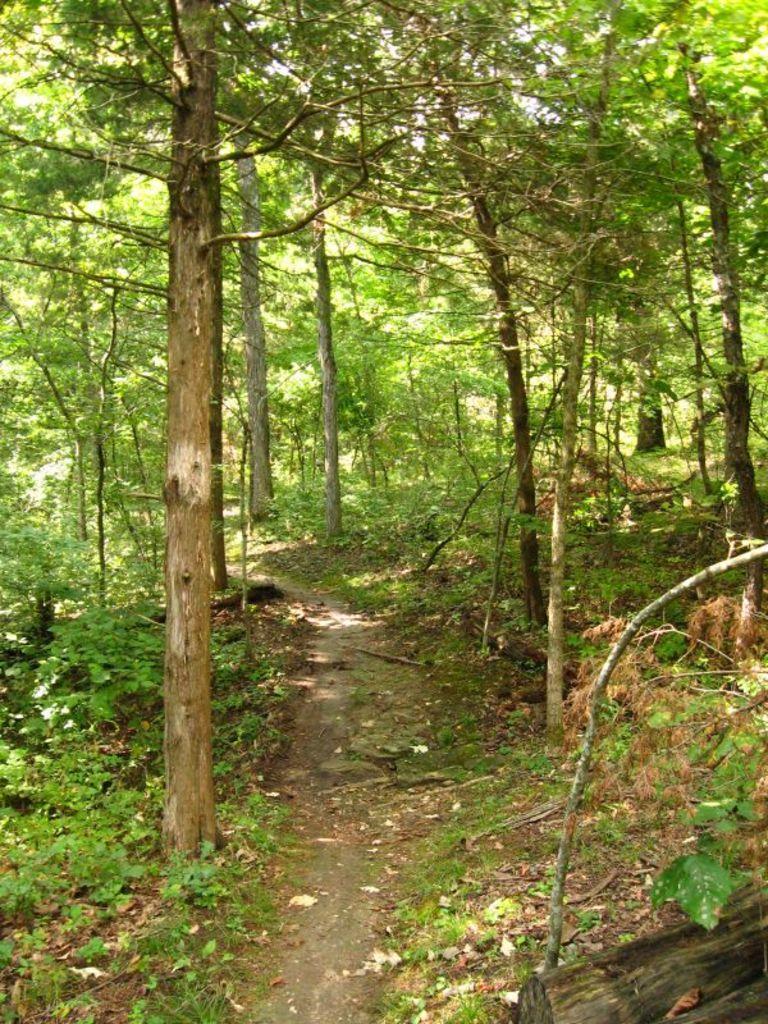Please provide a concise description of this image. In this image we can see a road, trees and plants on both the sides of the road. 